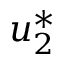Convert formula to latex. <formula><loc_0><loc_0><loc_500><loc_500>u _ { 2 } ^ { * }</formula> 